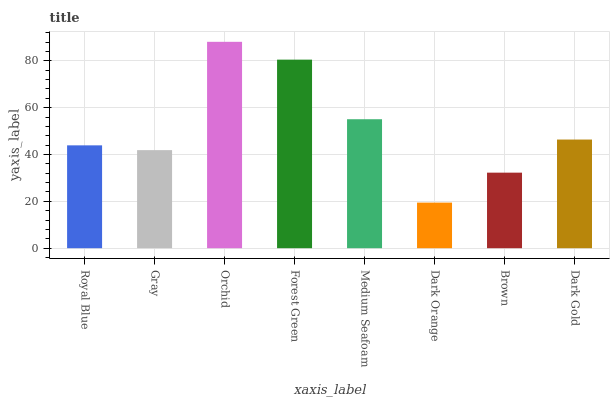Is Dark Orange the minimum?
Answer yes or no. Yes. Is Orchid the maximum?
Answer yes or no. Yes. Is Gray the minimum?
Answer yes or no. No. Is Gray the maximum?
Answer yes or no. No. Is Royal Blue greater than Gray?
Answer yes or no. Yes. Is Gray less than Royal Blue?
Answer yes or no. Yes. Is Gray greater than Royal Blue?
Answer yes or no. No. Is Royal Blue less than Gray?
Answer yes or no. No. Is Dark Gold the high median?
Answer yes or no. Yes. Is Royal Blue the low median?
Answer yes or no. Yes. Is Forest Green the high median?
Answer yes or no. No. Is Forest Green the low median?
Answer yes or no. No. 